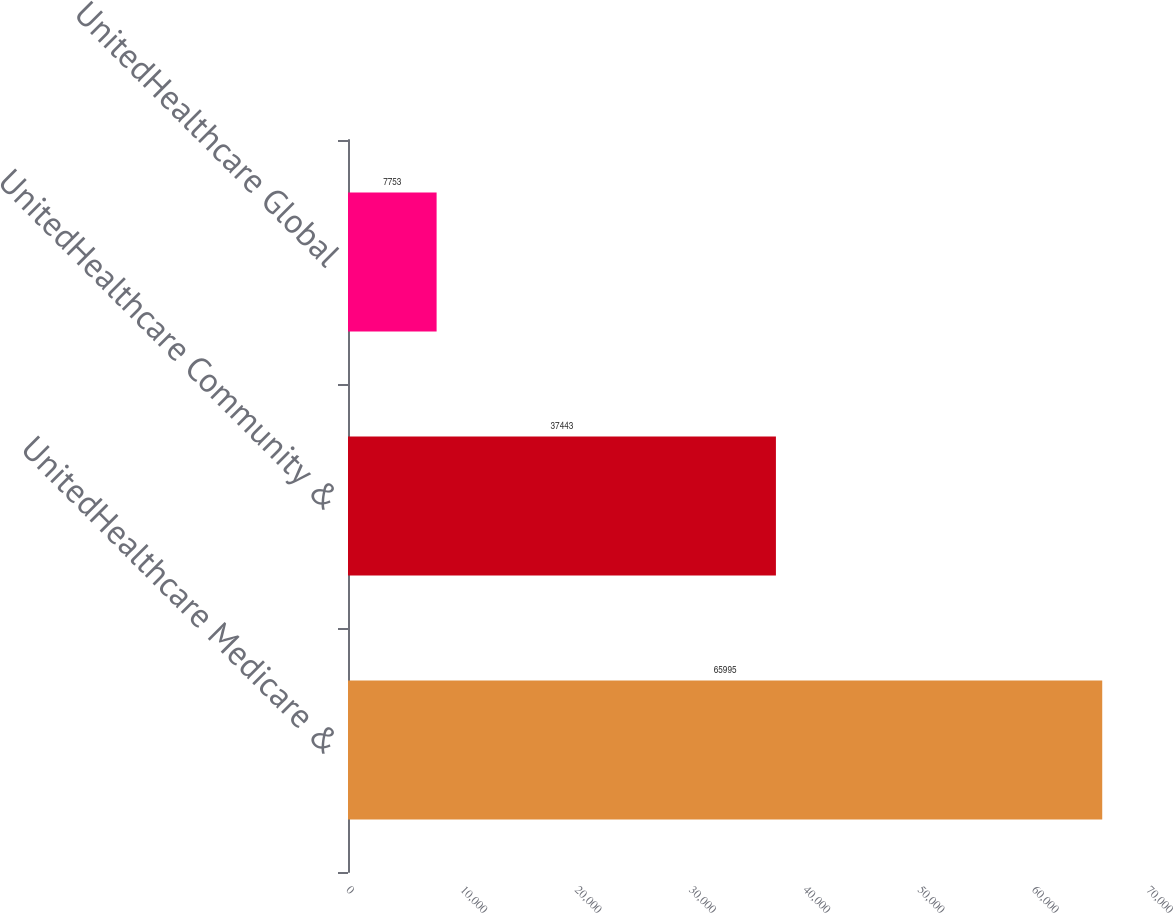Convert chart. <chart><loc_0><loc_0><loc_500><loc_500><bar_chart><fcel>UnitedHealthcare Medicare &<fcel>UnitedHealthcare Community &<fcel>UnitedHealthcare Global<nl><fcel>65995<fcel>37443<fcel>7753<nl></chart> 